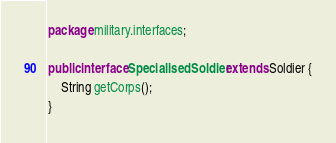Convert code to text. <code><loc_0><loc_0><loc_500><loc_500><_Java_>package military.interfaces;

public interface SpecialisedSoldier extends Soldier {
    String getCorps();
}
</code> 